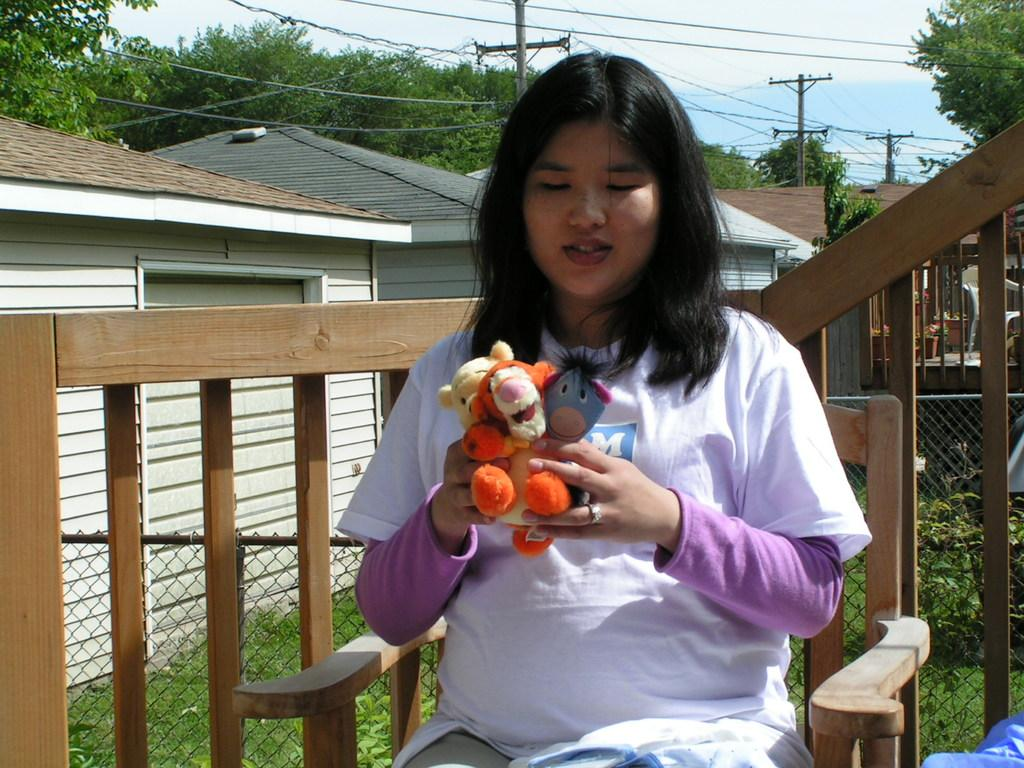What is the woman in the image doing? The woman is seated on a chair in the image. What is the woman holding in her hand? The woman is holding toys in her hand. What can be seen in the background of the image? There are buildings, poles, and trees in the background of the image. What is the woman's hope for her health in the image? There is no information about the woman's hope for her health in the image. 